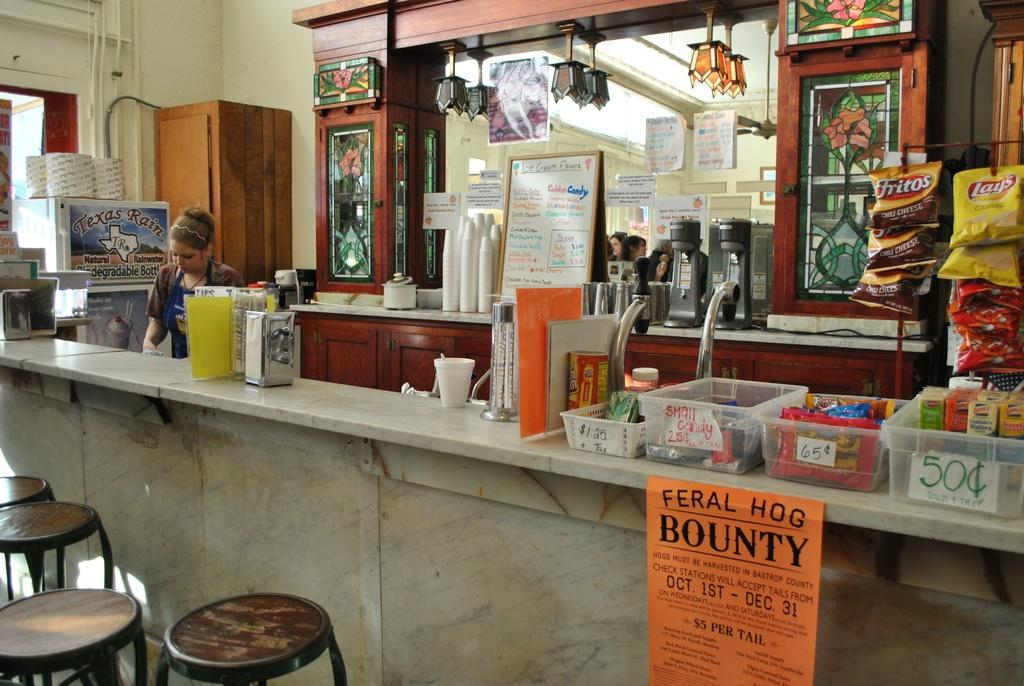Who is present in the image? There is a woman in the image. What type of furniture is visible in the image? There are stools in the image. What type of containers are present in the image? There are bowls in the image. What type of snack is visible in the image? Chips packets are visible in the image. What type of storage is present in the image? Cupboards are present in the image. What else can be seen in the image? There are other objects in the image. What is visible in the background of the image? There is a wall in the background of the image. What type of lettuce is being played on the guitar in the image? There is no guitar or lettuce present in the image. 